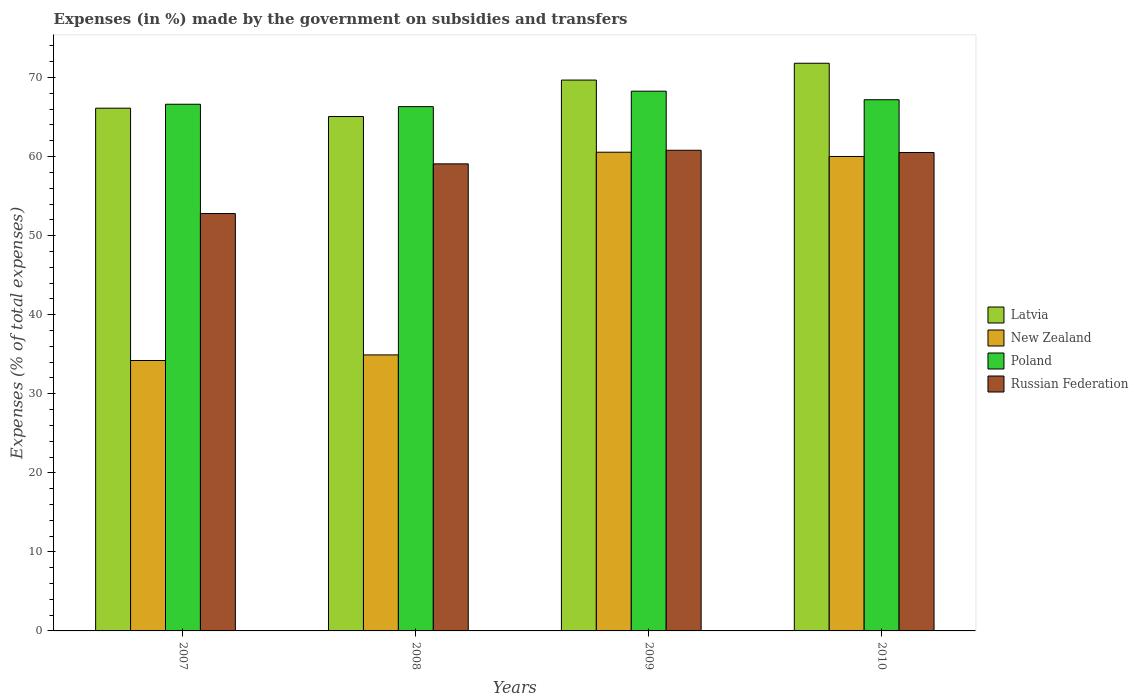Are the number of bars per tick equal to the number of legend labels?
Offer a very short reply. Yes. How many bars are there on the 1st tick from the left?
Give a very brief answer. 4. How many bars are there on the 2nd tick from the right?
Make the answer very short. 4. What is the percentage of expenses made by the government on subsidies and transfers in New Zealand in 2010?
Offer a very short reply. 60.02. Across all years, what is the maximum percentage of expenses made by the government on subsidies and transfers in New Zealand?
Offer a terse response. 60.55. Across all years, what is the minimum percentage of expenses made by the government on subsidies and transfers in Poland?
Your answer should be very brief. 66.32. In which year was the percentage of expenses made by the government on subsidies and transfers in Latvia maximum?
Provide a succinct answer. 2010. What is the total percentage of expenses made by the government on subsidies and transfers in Poland in the graph?
Your answer should be compact. 268.41. What is the difference between the percentage of expenses made by the government on subsidies and transfers in New Zealand in 2007 and that in 2009?
Offer a very short reply. -26.35. What is the difference between the percentage of expenses made by the government on subsidies and transfers in New Zealand in 2010 and the percentage of expenses made by the government on subsidies and transfers in Latvia in 2009?
Offer a terse response. -9.66. What is the average percentage of expenses made by the government on subsidies and transfers in New Zealand per year?
Keep it short and to the point. 47.42. In the year 2008, what is the difference between the percentage of expenses made by the government on subsidies and transfers in Poland and percentage of expenses made by the government on subsidies and transfers in New Zealand?
Your response must be concise. 31.4. In how many years, is the percentage of expenses made by the government on subsidies and transfers in Russian Federation greater than 62 %?
Your answer should be compact. 0. What is the ratio of the percentage of expenses made by the government on subsidies and transfers in Poland in 2008 to that in 2010?
Your answer should be very brief. 0.99. Is the percentage of expenses made by the government on subsidies and transfers in Poland in 2007 less than that in 2010?
Offer a terse response. Yes. What is the difference between the highest and the second highest percentage of expenses made by the government on subsidies and transfers in New Zealand?
Make the answer very short. 0.54. What is the difference between the highest and the lowest percentage of expenses made by the government on subsidies and transfers in Russian Federation?
Your answer should be compact. 8. Is the sum of the percentage of expenses made by the government on subsidies and transfers in Poland in 2007 and 2008 greater than the maximum percentage of expenses made by the government on subsidies and transfers in New Zealand across all years?
Your response must be concise. Yes. What does the 1st bar from the left in 2009 represents?
Your answer should be compact. Latvia. What does the 1st bar from the right in 2008 represents?
Make the answer very short. Russian Federation. Is it the case that in every year, the sum of the percentage of expenses made by the government on subsidies and transfers in Poland and percentage of expenses made by the government on subsidies and transfers in New Zealand is greater than the percentage of expenses made by the government on subsidies and transfers in Russian Federation?
Keep it short and to the point. Yes. How many bars are there?
Your response must be concise. 16. How many years are there in the graph?
Give a very brief answer. 4. What is the difference between two consecutive major ticks on the Y-axis?
Your response must be concise. 10. Does the graph contain any zero values?
Provide a short and direct response. No. Does the graph contain grids?
Offer a very short reply. No. Where does the legend appear in the graph?
Give a very brief answer. Center right. What is the title of the graph?
Your answer should be very brief. Expenses (in %) made by the government on subsidies and transfers. What is the label or title of the X-axis?
Your answer should be compact. Years. What is the label or title of the Y-axis?
Your answer should be compact. Expenses (% of total expenses). What is the Expenses (% of total expenses) in Latvia in 2007?
Make the answer very short. 66.12. What is the Expenses (% of total expenses) in New Zealand in 2007?
Keep it short and to the point. 34.21. What is the Expenses (% of total expenses) in Poland in 2007?
Your answer should be compact. 66.62. What is the Expenses (% of total expenses) in Russian Federation in 2007?
Provide a succinct answer. 52.8. What is the Expenses (% of total expenses) in Latvia in 2008?
Offer a terse response. 65.07. What is the Expenses (% of total expenses) of New Zealand in 2008?
Provide a succinct answer. 34.91. What is the Expenses (% of total expenses) of Poland in 2008?
Your response must be concise. 66.32. What is the Expenses (% of total expenses) of Russian Federation in 2008?
Offer a terse response. 59.08. What is the Expenses (% of total expenses) in Latvia in 2009?
Offer a very short reply. 69.68. What is the Expenses (% of total expenses) in New Zealand in 2009?
Your answer should be compact. 60.55. What is the Expenses (% of total expenses) of Poland in 2009?
Offer a terse response. 68.28. What is the Expenses (% of total expenses) in Russian Federation in 2009?
Keep it short and to the point. 60.8. What is the Expenses (% of total expenses) of Latvia in 2010?
Offer a very short reply. 71.81. What is the Expenses (% of total expenses) of New Zealand in 2010?
Your answer should be very brief. 60.02. What is the Expenses (% of total expenses) in Poland in 2010?
Your response must be concise. 67.19. What is the Expenses (% of total expenses) of Russian Federation in 2010?
Offer a very short reply. 60.52. Across all years, what is the maximum Expenses (% of total expenses) in Latvia?
Provide a short and direct response. 71.81. Across all years, what is the maximum Expenses (% of total expenses) of New Zealand?
Offer a very short reply. 60.55. Across all years, what is the maximum Expenses (% of total expenses) of Poland?
Your answer should be very brief. 68.28. Across all years, what is the maximum Expenses (% of total expenses) in Russian Federation?
Your answer should be compact. 60.8. Across all years, what is the minimum Expenses (% of total expenses) of Latvia?
Offer a terse response. 65.07. Across all years, what is the minimum Expenses (% of total expenses) in New Zealand?
Give a very brief answer. 34.21. Across all years, what is the minimum Expenses (% of total expenses) in Poland?
Offer a very short reply. 66.32. Across all years, what is the minimum Expenses (% of total expenses) in Russian Federation?
Make the answer very short. 52.8. What is the total Expenses (% of total expenses) of Latvia in the graph?
Ensure brevity in your answer.  272.68. What is the total Expenses (% of total expenses) in New Zealand in the graph?
Offer a terse response. 189.69. What is the total Expenses (% of total expenses) of Poland in the graph?
Your response must be concise. 268.41. What is the total Expenses (% of total expenses) in Russian Federation in the graph?
Keep it short and to the point. 233.19. What is the difference between the Expenses (% of total expenses) in Latvia in 2007 and that in 2008?
Offer a terse response. 1.06. What is the difference between the Expenses (% of total expenses) in New Zealand in 2007 and that in 2008?
Offer a very short reply. -0.71. What is the difference between the Expenses (% of total expenses) of Poland in 2007 and that in 2008?
Ensure brevity in your answer.  0.3. What is the difference between the Expenses (% of total expenses) in Russian Federation in 2007 and that in 2008?
Provide a short and direct response. -6.28. What is the difference between the Expenses (% of total expenses) in Latvia in 2007 and that in 2009?
Your answer should be compact. -3.55. What is the difference between the Expenses (% of total expenses) of New Zealand in 2007 and that in 2009?
Offer a terse response. -26.35. What is the difference between the Expenses (% of total expenses) in Poland in 2007 and that in 2009?
Give a very brief answer. -1.65. What is the difference between the Expenses (% of total expenses) of Russian Federation in 2007 and that in 2009?
Ensure brevity in your answer.  -8. What is the difference between the Expenses (% of total expenses) in Latvia in 2007 and that in 2010?
Offer a very short reply. -5.68. What is the difference between the Expenses (% of total expenses) in New Zealand in 2007 and that in 2010?
Your response must be concise. -25.81. What is the difference between the Expenses (% of total expenses) of Poland in 2007 and that in 2010?
Your answer should be compact. -0.57. What is the difference between the Expenses (% of total expenses) of Russian Federation in 2007 and that in 2010?
Keep it short and to the point. -7.72. What is the difference between the Expenses (% of total expenses) of Latvia in 2008 and that in 2009?
Keep it short and to the point. -4.61. What is the difference between the Expenses (% of total expenses) in New Zealand in 2008 and that in 2009?
Provide a short and direct response. -25.64. What is the difference between the Expenses (% of total expenses) of Poland in 2008 and that in 2009?
Make the answer very short. -1.96. What is the difference between the Expenses (% of total expenses) in Russian Federation in 2008 and that in 2009?
Offer a very short reply. -1.72. What is the difference between the Expenses (% of total expenses) of Latvia in 2008 and that in 2010?
Provide a short and direct response. -6.74. What is the difference between the Expenses (% of total expenses) of New Zealand in 2008 and that in 2010?
Keep it short and to the point. -25.1. What is the difference between the Expenses (% of total expenses) in Poland in 2008 and that in 2010?
Keep it short and to the point. -0.87. What is the difference between the Expenses (% of total expenses) in Russian Federation in 2008 and that in 2010?
Your response must be concise. -1.44. What is the difference between the Expenses (% of total expenses) in Latvia in 2009 and that in 2010?
Offer a very short reply. -2.13. What is the difference between the Expenses (% of total expenses) in New Zealand in 2009 and that in 2010?
Provide a short and direct response. 0.54. What is the difference between the Expenses (% of total expenses) of Poland in 2009 and that in 2010?
Make the answer very short. 1.08. What is the difference between the Expenses (% of total expenses) of Russian Federation in 2009 and that in 2010?
Offer a terse response. 0.28. What is the difference between the Expenses (% of total expenses) of Latvia in 2007 and the Expenses (% of total expenses) of New Zealand in 2008?
Offer a terse response. 31.21. What is the difference between the Expenses (% of total expenses) in Latvia in 2007 and the Expenses (% of total expenses) in Poland in 2008?
Your answer should be very brief. -0.19. What is the difference between the Expenses (% of total expenses) of Latvia in 2007 and the Expenses (% of total expenses) of Russian Federation in 2008?
Keep it short and to the point. 7.04. What is the difference between the Expenses (% of total expenses) in New Zealand in 2007 and the Expenses (% of total expenses) in Poland in 2008?
Offer a terse response. -32.11. What is the difference between the Expenses (% of total expenses) of New Zealand in 2007 and the Expenses (% of total expenses) of Russian Federation in 2008?
Offer a terse response. -24.87. What is the difference between the Expenses (% of total expenses) of Poland in 2007 and the Expenses (% of total expenses) of Russian Federation in 2008?
Provide a succinct answer. 7.54. What is the difference between the Expenses (% of total expenses) of Latvia in 2007 and the Expenses (% of total expenses) of New Zealand in 2009?
Ensure brevity in your answer.  5.57. What is the difference between the Expenses (% of total expenses) of Latvia in 2007 and the Expenses (% of total expenses) of Poland in 2009?
Keep it short and to the point. -2.15. What is the difference between the Expenses (% of total expenses) of Latvia in 2007 and the Expenses (% of total expenses) of Russian Federation in 2009?
Give a very brief answer. 5.32. What is the difference between the Expenses (% of total expenses) of New Zealand in 2007 and the Expenses (% of total expenses) of Poland in 2009?
Keep it short and to the point. -34.07. What is the difference between the Expenses (% of total expenses) of New Zealand in 2007 and the Expenses (% of total expenses) of Russian Federation in 2009?
Offer a very short reply. -26.59. What is the difference between the Expenses (% of total expenses) of Poland in 2007 and the Expenses (% of total expenses) of Russian Federation in 2009?
Provide a short and direct response. 5.82. What is the difference between the Expenses (% of total expenses) in Latvia in 2007 and the Expenses (% of total expenses) in New Zealand in 2010?
Ensure brevity in your answer.  6.11. What is the difference between the Expenses (% of total expenses) in Latvia in 2007 and the Expenses (% of total expenses) in Poland in 2010?
Make the answer very short. -1.07. What is the difference between the Expenses (% of total expenses) of Latvia in 2007 and the Expenses (% of total expenses) of Russian Federation in 2010?
Your response must be concise. 5.61. What is the difference between the Expenses (% of total expenses) of New Zealand in 2007 and the Expenses (% of total expenses) of Poland in 2010?
Make the answer very short. -32.99. What is the difference between the Expenses (% of total expenses) in New Zealand in 2007 and the Expenses (% of total expenses) in Russian Federation in 2010?
Offer a terse response. -26.31. What is the difference between the Expenses (% of total expenses) in Poland in 2007 and the Expenses (% of total expenses) in Russian Federation in 2010?
Ensure brevity in your answer.  6.1. What is the difference between the Expenses (% of total expenses) of Latvia in 2008 and the Expenses (% of total expenses) of New Zealand in 2009?
Keep it short and to the point. 4.51. What is the difference between the Expenses (% of total expenses) of Latvia in 2008 and the Expenses (% of total expenses) of Poland in 2009?
Offer a very short reply. -3.21. What is the difference between the Expenses (% of total expenses) of Latvia in 2008 and the Expenses (% of total expenses) of Russian Federation in 2009?
Provide a succinct answer. 4.27. What is the difference between the Expenses (% of total expenses) in New Zealand in 2008 and the Expenses (% of total expenses) in Poland in 2009?
Provide a short and direct response. -33.36. What is the difference between the Expenses (% of total expenses) in New Zealand in 2008 and the Expenses (% of total expenses) in Russian Federation in 2009?
Your answer should be compact. -25.88. What is the difference between the Expenses (% of total expenses) of Poland in 2008 and the Expenses (% of total expenses) of Russian Federation in 2009?
Ensure brevity in your answer.  5.52. What is the difference between the Expenses (% of total expenses) of Latvia in 2008 and the Expenses (% of total expenses) of New Zealand in 2010?
Your answer should be very brief. 5.05. What is the difference between the Expenses (% of total expenses) in Latvia in 2008 and the Expenses (% of total expenses) in Poland in 2010?
Keep it short and to the point. -2.13. What is the difference between the Expenses (% of total expenses) of Latvia in 2008 and the Expenses (% of total expenses) of Russian Federation in 2010?
Give a very brief answer. 4.55. What is the difference between the Expenses (% of total expenses) of New Zealand in 2008 and the Expenses (% of total expenses) of Poland in 2010?
Provide a succinct answer. -32.28. What is the difference between the Expenses (% of total expenses) of New Zealand in 2008 and the Expenses (% of total expenses) of Russian Federation in 2010?
Keep it short and to the point. -25.6. What is the difference between the Expenses (% of total expenses) in Poland in 2008 and the Expenses (% of total expenses) in Russian Federation in 2010?
Offer a very short reply. 5.8. What is the difference between the Expenses (% of total expenses) of Latvia in 2009 and the Expenses (% of total expenses) of New Zealand in 2010?
Offer a terse response. 9.66. What is the difference between the Expenses (% of total expenses) in Latvia in 2009 and the Expenses (% of total expenses) in Poland in 2010?
Offer a terse response. 2.49. What is the difference between the Expenses (% of total expenses) of Latvia in 2009 and the Expenses (% of total expenses) of Russian Federation in 2010?
Ensure brevity in your answer.  9.16. What is the difference between the Expenses (% of total expenses) of New Zealand in 2009 and the Expenses (% of total expenses) of Poland in 2010?
Keep it short and to the point. -6.64. What is the difference between the Expenses (% of total expenses) in New Zealand in 2009 and the Expenses (% of total expenses) in Russian Federation in 2010?
Offer a terse response. 0.04. What is the difference between the Expenses (% of total expenses) of Poland in 2009 and the Expenses (% of total expenses) of Russian Federation in 2010?
Keep it short and to the point. 7.76. What is the average Expenses (% of total expenses) in Latvia per year?
Give a very brief answer. 68.17. What is the average Expenses (% of total expenses) of New Zealand per year?
Your answer should be very brief. 47.42. What is the average Expenses (% of total expenses) of Poland per year?
Provide a short and direct response. 67.1. What is the average Expenses (% of total expenses) in Russian Federation per year?
Your answer should be very brief. 58.3. In the year 2007, what is the difference between the Expenses (% of total expenses) in Latvia and Expenses (% of total expenses) in New Zealand?
Your answer should be very brief. 31.92. In the year 2007, what is the difference between the Expenses (% of total expenses) of Latvia and Expenses (% of total expenses) of Poland?
Provide a short and direct response. -0.5. In the year 2007, what is the difference between the Expenses (% of total expenses) in Latvia and Expenses (% of total expenses) in Russian Federation?
Provide a succinct answer. 13.33. In the year 2007, what is the difference between the Expenses (% of total expenses) in New Zealand and Expenses (% of total expenses) in Poland?
Provide a short and direct response. -32.42. In the year 2007, what is the difference between the Expenses (% of total expenses) in New Zealand and Expenses (% of total expenses) in Russian Federation?
Offer a very short reply. -18.59. In the year 2007, what is the difference between the Expenses (% of total expenses) of Poland and Expenses (% of total expenses) of Russian Federation?
Your answer should be compact. 13.82. In the year 2008, what is the difference between the Expenses (% of total expenses) of Latvia and Expenses (% of total expenses) of New Zealand?
Keep it short and to the point. 30.15. In the year 2008, what is the difference between the Expenses (% of total expenses) in Latvia and Expenses (% of total expenses) in Poland?
Offer a terse response. -1.25. In the year 2008, what is the difference between the Expenses (% of total expenses) in Latvia and Expenses (% of total expenses) in Russian Federation?
Offer a very short reply. 5.99. In the year 2008, what is the difference between the Expenses (% of total expenses) in New Zealand and Expenses (% of total expenses) in Poland?
Your response must be concise. -31.4. In the year 2008, what is the difference between the Expenses (% of total expenses) in New Zealand and Expenses (% of total expenses) in Russian Federation?
Offer a very short reply. -24.17. In the year 2008, what is the difference between the Expenses (% of total expenses) of Poland and Expenses (% of total expenses) of Russian Federation?
Your answer should be very brief. 7.24. In the year 2009, what is the difference between the Expenses (% of total expenses) of Latvia and Expenses (% of total expenses) of New Zealand?
Your response must be concise. 9.12. In the year 2009, what is the difference between the Expenses (% of total expenses) of Latvia and Expenses (% of total expenses) of Poland?
Provide a short and direct response. 1.4. In the year 2009, what is the difference between the Expenses (% of total expenses) in Latvia and Expenses (% of total expenses) in Russian Federation?
Your response must be concise. 8.88. In the year 2009, what is the difference between the Expenses (% of total expenses) in New Zealand and Expenses (% of total expenses) in Poland?
Give a very brief answer. -7.72. In the year 2009, what is the difference between the Expenses (% of total expenses) in New Zealand and Expenses (% of total expenses) in Russian Federation?
Your answer should be compact. -0.24. In the year 2009, what is the difference between the Expenses (% of total expenses) of Poland and Expenses (% of total expenses) of Russian Federation?
Keep it short and to the point. 7.48. In the year 2010, what is the difference between the Expenses (% of total expenses) of Latvia and Expenses (% of total expenses) of New Zealand?
Make the answer very short. 11.79. In the year 2010, what is the difference between the Expenses (% of total expenses) of Latvia and Expenses (% of total expenses) of Poland?
Provide a short and direct response. 4.61. In the year 2010, what is the difference between the Expenses (% of total expenses) of Latvia and Expenses (% of total expenses) of Russian Federation?
Give a very brief answer. 11.29. In the year 2010, what is the difference between the Expenses (% of total expenses) of New Zealand and Expenses (% of total expenses) of Poland?
Keep it short and to the point. -7.18. In the year 2010, what is the difference between the Expenses (% of total expenses) of New Zealand and Expenses (% of total expenses) of Russian Federation?
Your response must be concise. -0.5. In the year 2010, what is the difference between the Expenses (% of total expenses) of Poland and Expenses (% of total expenses) of Russian Federation?
Your answer should be compact. 6.68. What is the ratio of the Expenses (% of total expenses) in Latvia in 2007 to that in 2008?
Offer a very short reply. 1.02. What is the ratio of the Expenses (% of total expenses) of New Zealand in 2007 to that in 2008?
Provide a succinct answer. 0.98. What is the ratio of the Expenses (% of total expenses) in Russian Federation in 2007 to that in 2008?
Your answer should be compact. 0.89. What is the ratio of the Expenses (% of total expenses) in Latvia in 2007 to that in 2009?
Offer a terse response. 0.95. What is the ratio of the Expenses (% of total expenses) of New Zealand in 2007 to that in 2009?
Your answer should be compact. 0.56. What is the ratio of the Expenses (% of total expenses) in Poland in 2007 to that in 2009?
Offer a terse response. 0.98. What is the ratio of the Expenses (% of total expenses) of Russian Federation in 2007 to that in 2009?
Provide a short and direct response. 0.87. What is the ratio of the Expenses (% of total expenses) in Latvia in 2007 to that in 2010?
Make the answer very short. 0.92. What is the ratio of the Expenses (% of total expenses) of New Zealand in 2007 to that in 2010?
Provide a short and direct response. 0.57. What is the ratio of the Expenses (% of total expenses) in Russian Federation in 2007 to that in 2010?
Make the answer very short. 0.87. What is the ratio of the Expenses (% of total expenses) in Latvia in 2008 to that in 2009?
Offer a terse response. 0.93. What is the ratio of the Expenses (% of total expenses) of New Zealand in 2008 to that in 2009?
Offer a very short reply. 0.58. What is the ratio of the Expenses (% of total expenses) in Poland in 2008 to that in 2009?
Offer a terse response. 0.97. What is the ratio of the Expenses (% of total expenses) in Russian Federation in 2008 to that in 2009?
Give a very brief answer. 0.97. What is the ratio of the Expenses (% of total expenses) in Latvia in 2008 to that in 2010?
Offer a very short reply. 0.91. What is the ratio of the Expenses (% of total expenses) of New Zealand in 2008 to that in 2010?
Your answer should be compact. 0.58. What is the ratio of the Expenses (% of total expenses) of Russian Federation in 2008 to that in 2010?
Your response must be concise. 0.98. What is the ratio of the Expenses (% of total expenses) of Latvia in 2009 to that in 2010?
Keep it short and to the point. 0.97. What is the ratio of the Expenses (% of total expenses) of Poland in 2009 to that in 2010?
Provide a succinct answer. 1.02. What is the difference between the highest and the second highest Expenses (% of total expenses) in Latvia?
Provide a succinct answer. 2.13. What is the difference between the highest and the second highest Expenses (% of total expenses) in New Zealand?
Ensure brevity in your answer.  0.54. What is the difference between the highest and the second highest Expenses (% of total expenses) in Poland?
Provide a succinct answer. 1.08. What is the difference between the highest and the second highest Expenses (% of total expenses) of Russian Federation?
Ensure brevity in your answer.  0.28. What is the difference between the highest and the lowest Expenses (% of total expenses) of Latvia?
Make the answer very short. 6.74. What is the difference between the highest and the lowest Expenses (% of total expenses) in New Zealand?
Your response must be concise. 26.35. What is the difference between the highest and the lowest Expenses (% of total expenses) of Poland?
Keep it short and to the point. 1.96. What is the difference between the highest and the lowest Expenses (% of total expenses) of Russian Federation?
Provide a succinct answer. 8. 